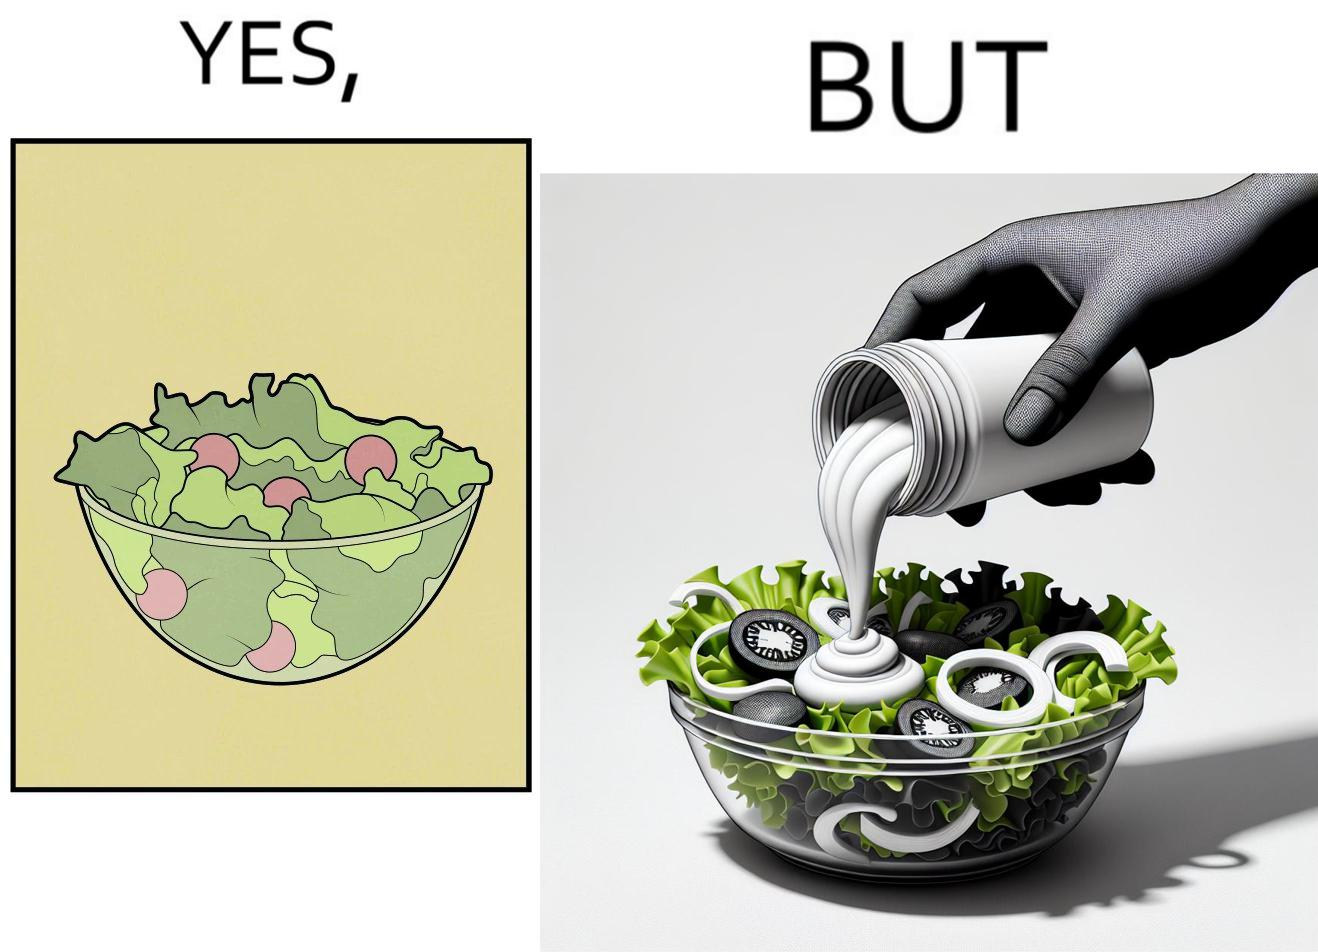Is there satirical content in this image? Yes, this image is satirical. 